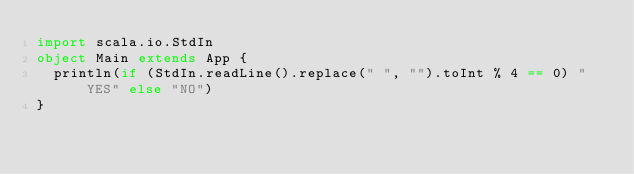<code> <loc_0><loc_0><loc_500><loc_500><_Scala_>import scala.io.StdIn
object Main extends App {
  println(if (StdIn.readLine().replace(" ", "").toInt % 4 == 0) "YES" else "NO")
}
</code> 